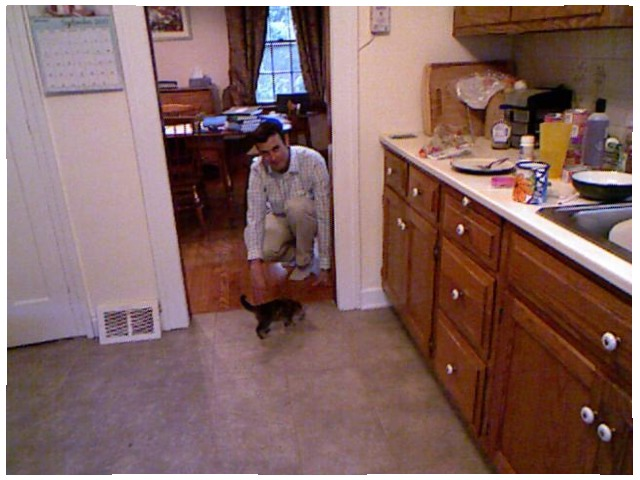<image>
Is the man in front of the cat? Yes. The man is positioned in front of the cat, appearing closer to the camera viewpoint. Is there a cat on the floor? Yes. Looking at the image, I can see the cat is positioned on top of the floor, with the floor providing support. Where is the cat in relation to the wood floor? Is it on the wood floor? No. The cat is not positioned on the wood floor. They may be near each other, but the cat is not supported by or resting on top of the wood floor. Where is the person in relation to the cat? Is it above the cat? No. The person is not positioned above the cat. The vertical arrangement shows a different relationship. Is there a man in the door? No. The man is not contained within the door. These objects have a different spatial relationship. Where is the person in relation to the cat? Is it next to the cat? Yes. The person is positioned adjacent to the cat, located nearby in the same general area. Is there a cat next to the person? No. The cat is not positioned next to the person. They are located in different areas of the scene. 